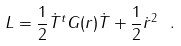Convert formula to latex. <formula><loc_0><loc_0><loc_500><loc_500>L = \frac { 1 } { 2 } \dot { T } ^ { t } G ( r ) \dot { T } + \frac { 1 } { 2 } \dot { r } ^ { 2 } \ .</formula> 